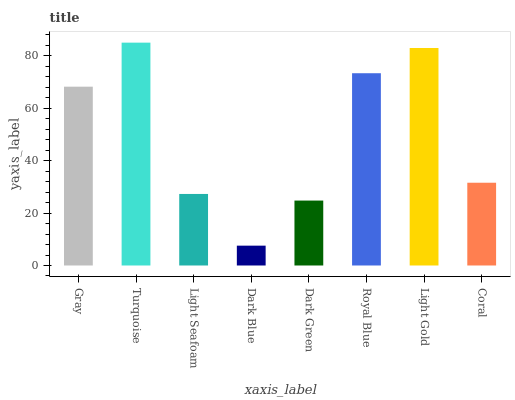Is Dark Blue the minimum?
Answer yes or no. Yes. Is Turquoise the maximum?
Answer yes or no. Yes. Is Light Seafoam the minimum?
Answer yes or no. No. Is Light Seafoam the maximum?
Answer yes or no. No. Is Turquoise greater than Light Seafoam?
Answer yes or no. Yes. Is Light Seafoam less than Turquoise?
Answer yes or no. Yes. Is Light Seafoam greater than Turquoise?
Answer yes or no. No. Is Turquoise less than Light Seafoam?
Answer yes or no. No. Is Gray the high median?
Answer yes or no. Yes. Is Coral the low median?
Answer yes or no. Yes. Is Dark Blue the high median?
Answer yes or no. No. Is Gray the low median?
Answer yes or no. No. 